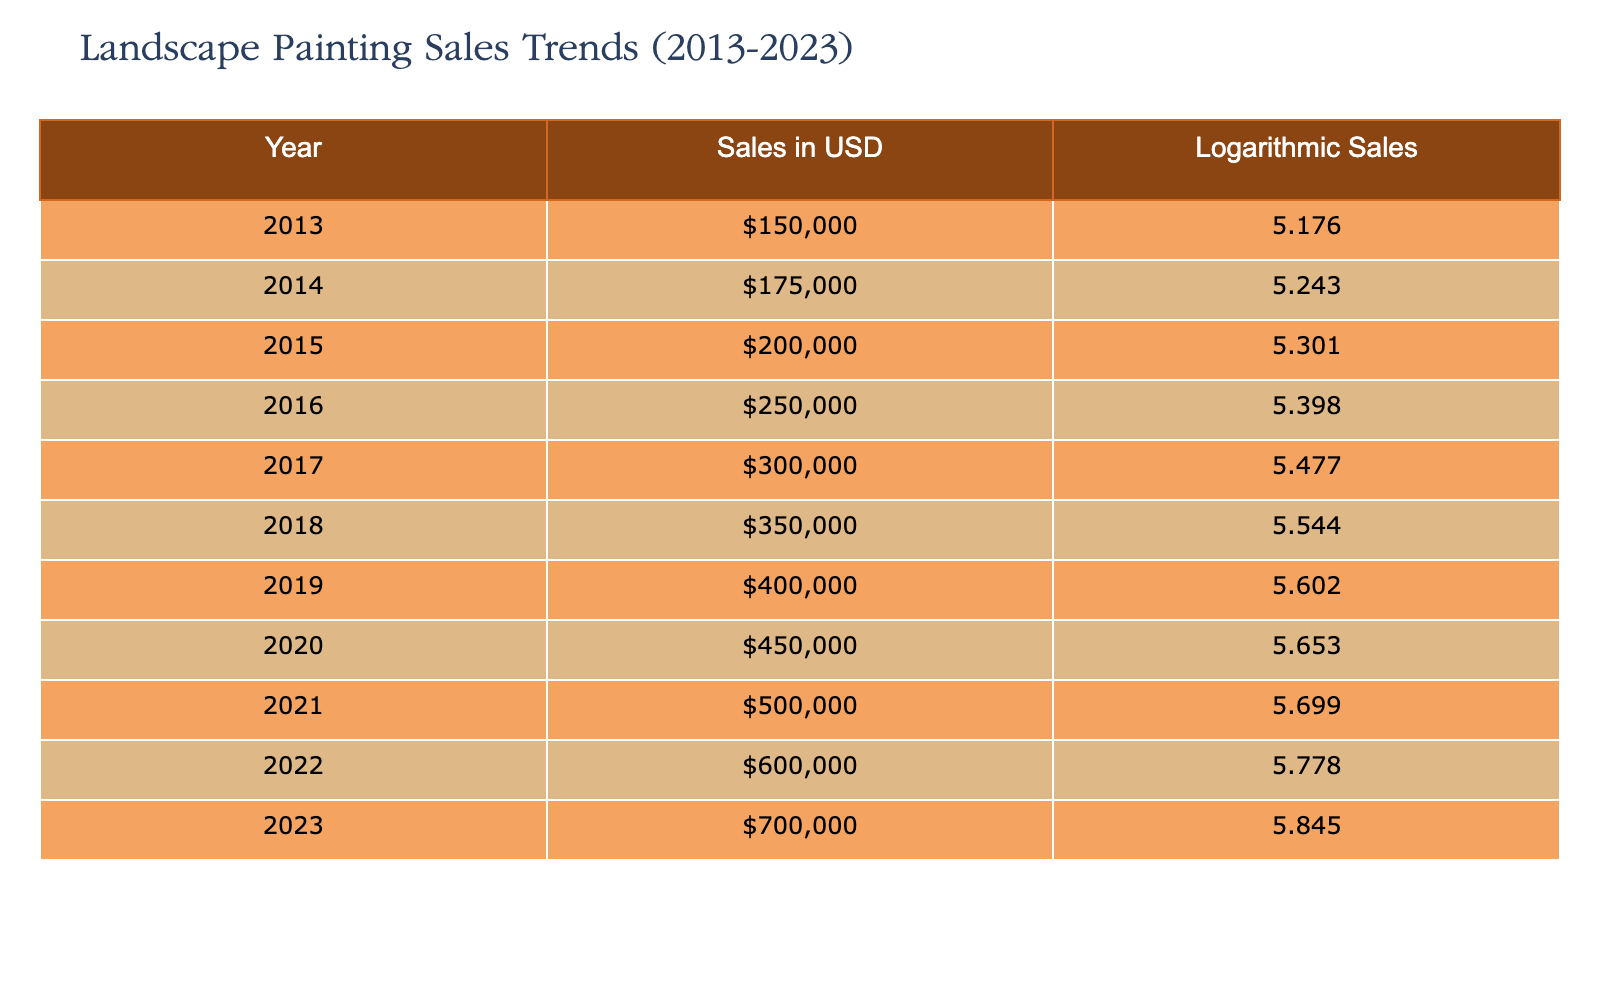What was the total sales in USD for the year 2023? According to the table, the sales in USD for the year 2023 is directly listed as 700000.
Answer: 700000 What were the logarithmic sales for the year 2015? The table shows that the logarithmic sales for the year 2015 is recorded as 5.301.
Answer: 5.301 In which year did sales first exceed 300000 USD? Looking at the sales figures, 300000 USD was first exceeded in the year 2017, where the sales figure is 300000.
Answer: 2017 What is the average sales value over the ten years? To find the average, add all sales values together: (150000 + 175000 + 200000 + 250000 + 300000 + 350000 + 400000 + 450000 + 500000 + 600000 + 700000) = 3575000. Dividing this sum by 11 gives an average of 325000.
Answer: 325000 Did the sales figure increase every year from 2013 to 2023? By examining the sales figures, each year shows a higher figure than the previous one, indicating a consistent increase each year.
Answer: Yes How much did the sales in USD increase from 2015 to 2023? The sales for 2015 was 200000 and for 2023 was 700000. The increase can be found by subtracting these two values: 700000 - 200000 = 500000.
Answer: 500000 What was the difference between the highest and lowest sales recorded? From the data, the highest sales recorded in 2023 is 700000 and the lowest in 2013 is 150000. The difference is calculated as 700000 - 150000 = 550000.
Answer: 550000 Which year had the highest logarithmic sales? The logarithmic sales are highest in the year 2023, where the value is recorded as 5.845.
Answer: 2023 Is it true that the sales in 2020 were less than in 2018? The table shows that in 2020 the sales were 450000, while in 2018 they were 350000, indicating that sales in 2020 were indeed greater.
Answer: No 